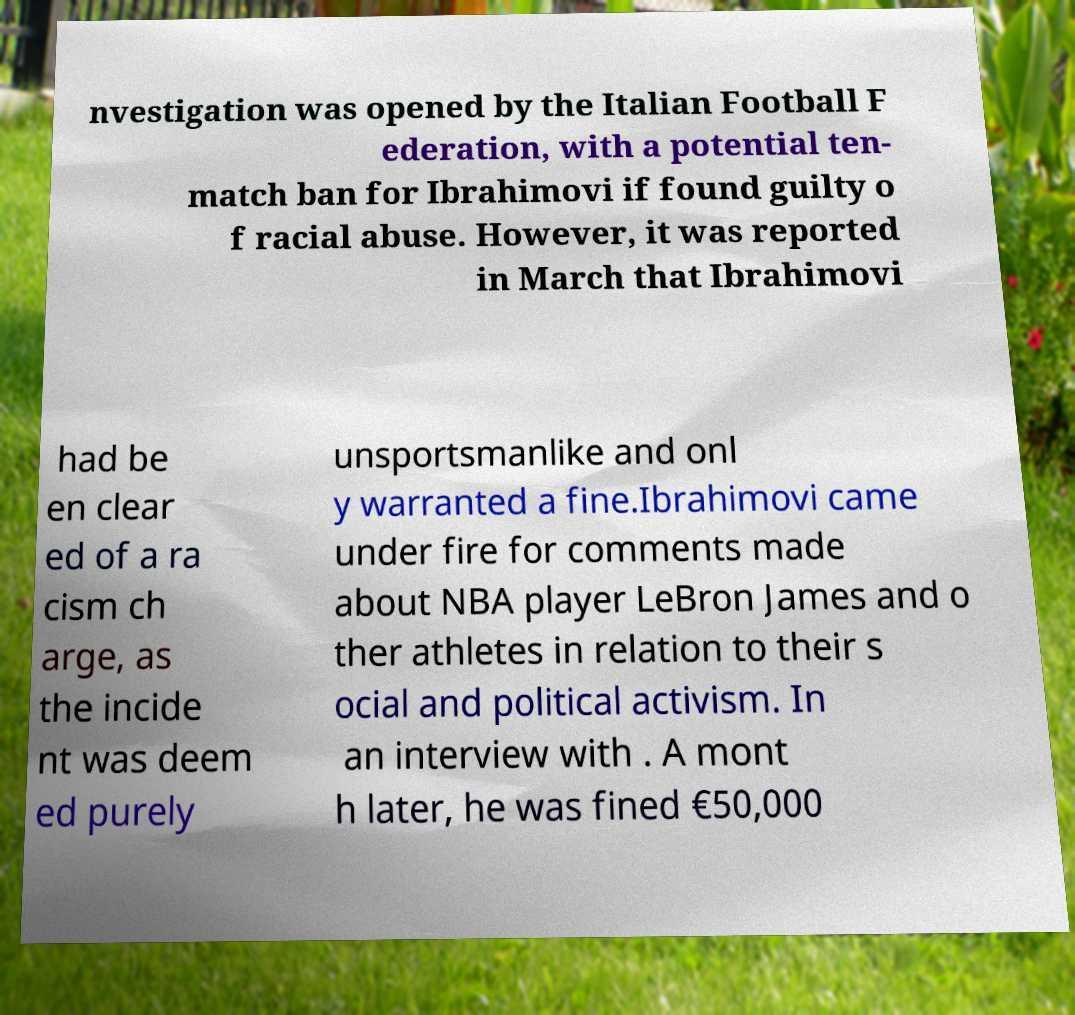Please identify and transcribe the text found in this image. nvestigation was opened by the Italian Football F ederation, with a potential ten- match ban for Ibrahimovi if found guilty o f racial abuse. However, it was reported in March that Ibrahimovi had be en clear ed of a ra cism ch arge, as the incide nt was deem ed purely unsportsmanlike and onl y warranted a fine.Ibrahimovi came under fire for comments made about NBA player LeBron James and o ther athletes in relation to their s ocial and political activism. In an interview with . A mont h later, he was fined €50,000 